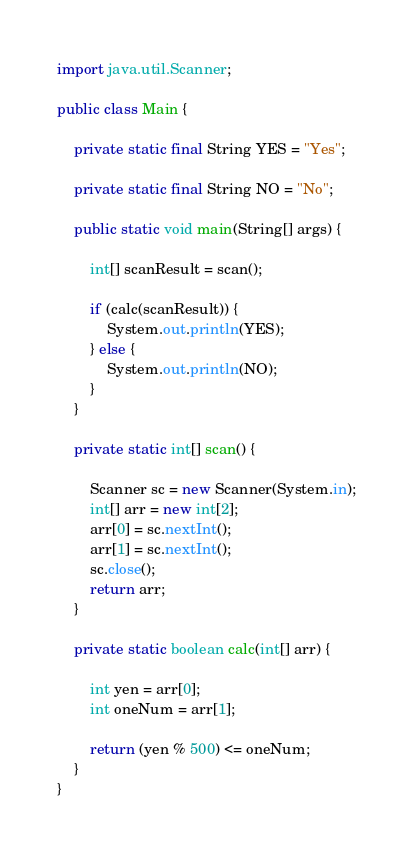Convert code to text. <code><loc_0><loc_0><loc_500><loc_500><_Java_>import java.util.Scanner;

public class Main {

	private static final String YES = "Yes";

	private static final String NO = "No";

	public static void main(String[] args) {

		int[] scanResult = scan();

		if (calc(scanResult)) {
			System.out.println(YES);
		} else {
			System.out.println(NO);
		}
	}

	private static int[] scan() {

		Scanner sc = new Scanner(System.in);
		int[] arr = new int[2];
		arr[0] = sc.nextInt();
		arr[1] = sc.nextInt();
		sc.close();
		return arr;
	}

	private static boolean calc(int[] arr) {

		int yen = arr[0];
		int oneNum = arr[1];

		return (yen % 500) <= oneNum;
	}
}</code> 